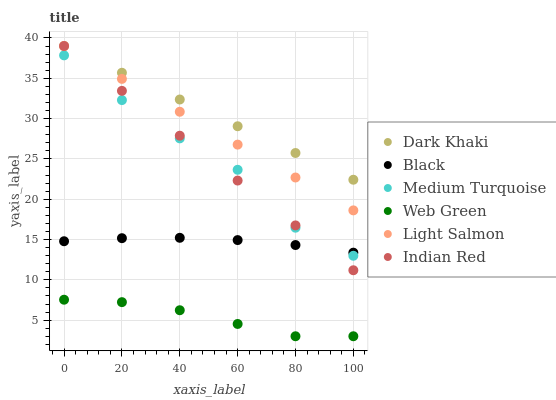Does Web Green have the minimum area under the curve?
Answer yes or no. Yes. Does Dark Khaki have the maximum area under the curve?
Answer yes or no. Yes. Does Medium Turquoise have the minimum area under the curve?
Answer yes or no. No. Does Medium Turquoise have the maximum area under the curve?
Answer yes or no. No. Is Light Salmon the smoothest?
Answer yes or no. Yes. Is Medium Turquoise the roughest?
Answer yes or no. Yes. Is Web Green the smoothest?
Answer yes or no. No. Is Web Green the roughest?
Answer yes or no. No. Does Web Green have the lowest value?
Answer yes or no. Yes. Does Medium Turquoise have the lowest value?
Answer yes or no. No. Does Indian Red have the highest value?
Answer yes or no. Yes. Does Medium Turquoise have the highest value?
Answer yes or no. No. Is Web Green less than Black?
Answer yes or no. Yes. Is Light Salmon greater than Medium Turquoise?
Answer yes or no. Yes. Does Indian Red intersect Black?
Answer yes or no. Yes. Is Indian Red less than Black?
Answer yes or no. No. Is Indian Red greater than Black?
Answer yes or no. No. Does Web Green intersect Black?
Answer yes or no. No. 